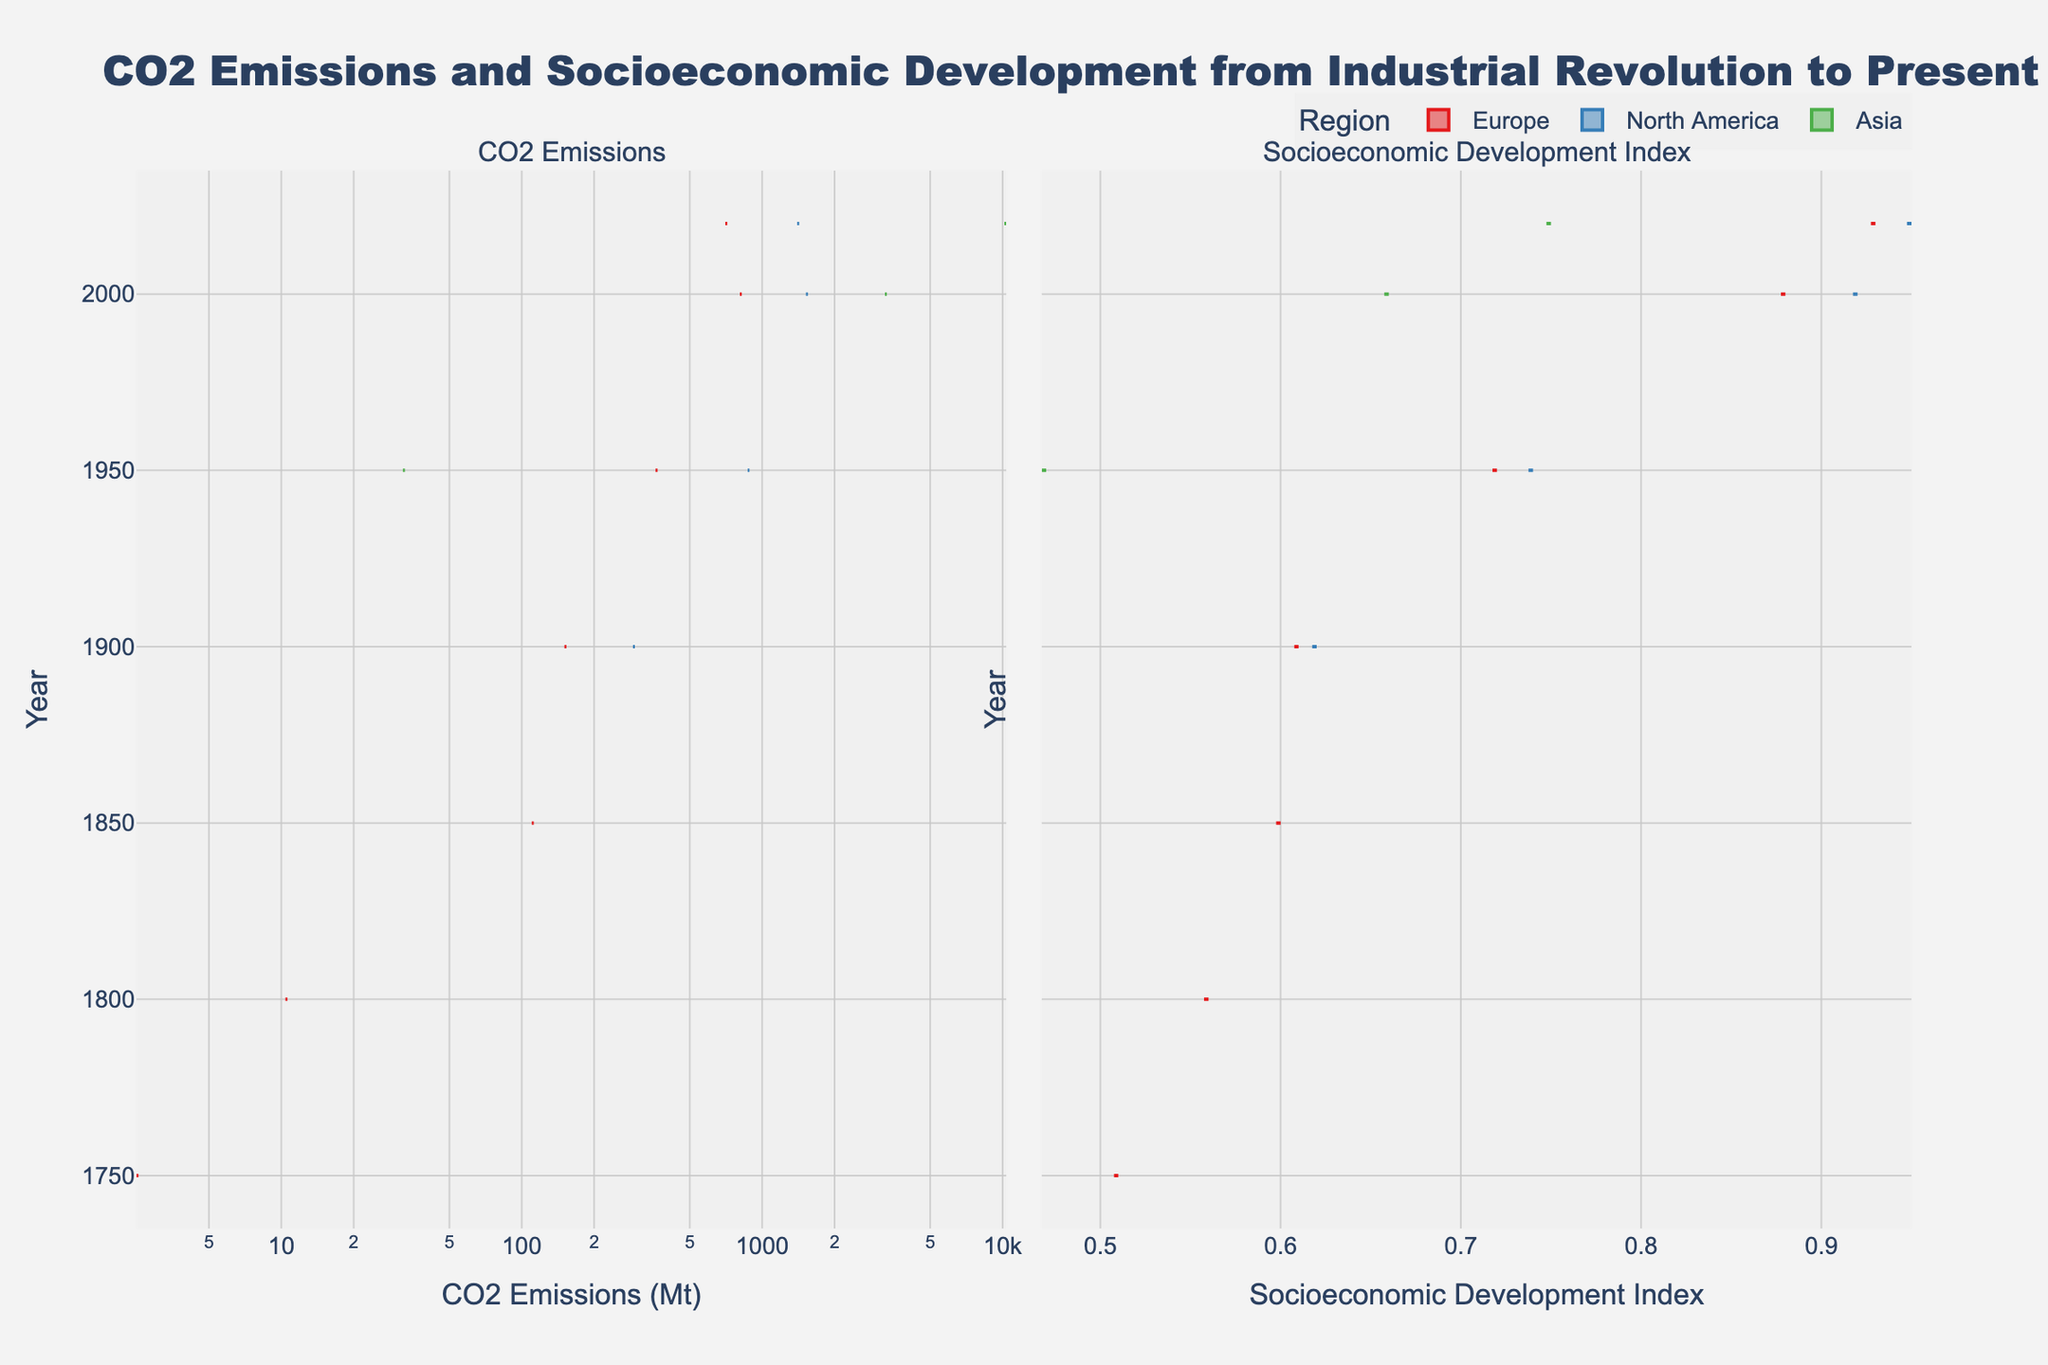What is the title of the figure? The title is located at the top center of the figure and indicates the main topic of the visualization.
Answer: CO2 Emissions and Socioeconomic Development from Industrial Revolution to Present Which region shows the highest CO2 emissions in 2020? Look at the 2020 data for CO2 emissions in the CO2 Emissions plot on the left. Identify the highest data point.
Answer: Asia How has the Socioeconomic Development Index changed for Germany from 1900 to 2020? Examine the Socioeconomic Development Index plot on the right. Compare the values for Germany in 1900 and 2020.
Answer: Increased from 0.61 to 0.93 Which country had higher CO2 emissions in 1950, Germany or the United States? Check the CO2 Emissions plot for the year 1950 and compare the values for Germany and the United States.
Answer: United States What is the difference in CO2 emissions between China and the United States in 2000? Find the CO2 emissions for China and the United States in 2000, then subtract the value for the United States from the value for China.
Answer: 1717.1 Mt Which region has the largest spread in Socioeconomic Development Index values over time? Compare the width of the violins in the Socioeconomic Development Index plot. The region with the largest spread will have the widest violin shape over time.
Answer: Europe What is the log scale of the x-axis used in the CO2 Emissions plot? The appearance of non-linear spacing between tick marks on the CO2 Emissions x-axis indicates a logarithmic scale. Note the axis title indicating the use of logarithmic scale.
Answer: Logarithmic scale Which country had a higher Socioeconomic Development Index in 2000, China or Germany? Check the Socioeconomic Development Index values for China and Germany in 2000 in the Socioeconomic Development Index plot.
Answer: Germany During which year did the United States have CO2 emissions higher than 1000 Mt for the first time? Follow the United States data points in the CO2 Emissions plot. Identify the first year where the value surpasses 1000 Mt.
Answer: 2000 How have CO2 emissions in Europe changed from 1750 to 2020? Look at the CO2 Emissions plot from 1750 to 2020 for Europe. Note the change in values over this time range.
Answer: Increased significantly 